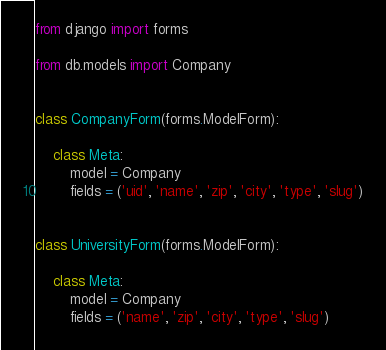<code> <loc_0><loc_0><loc_500><loc_500><_Python_>from django import forms

from db.models import Company


class CompanyForm(forms.ModelForm):

    class Meta:
        model = Company
        fields = ('uid', 'name', 'zip', 'city', 'type', 'slug')


class UniversityForm(forms.ModelForm):

    class Meta:
        model = Company
        fields = ('name', 'zip', 'city', 'type', 'slug')
</code> 